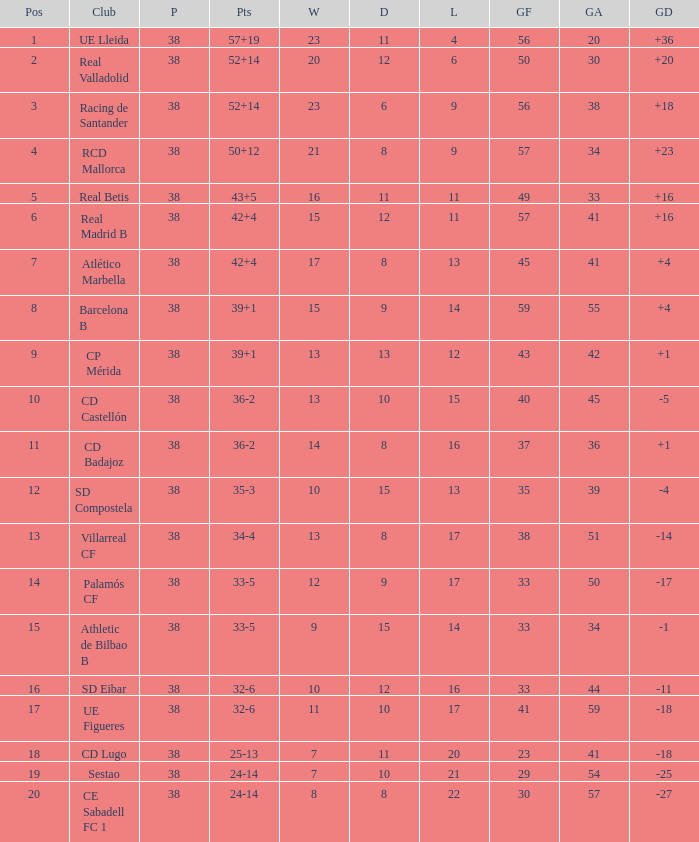What is the average goal difference with 51 goals scored against and less than 17 losses? None. 